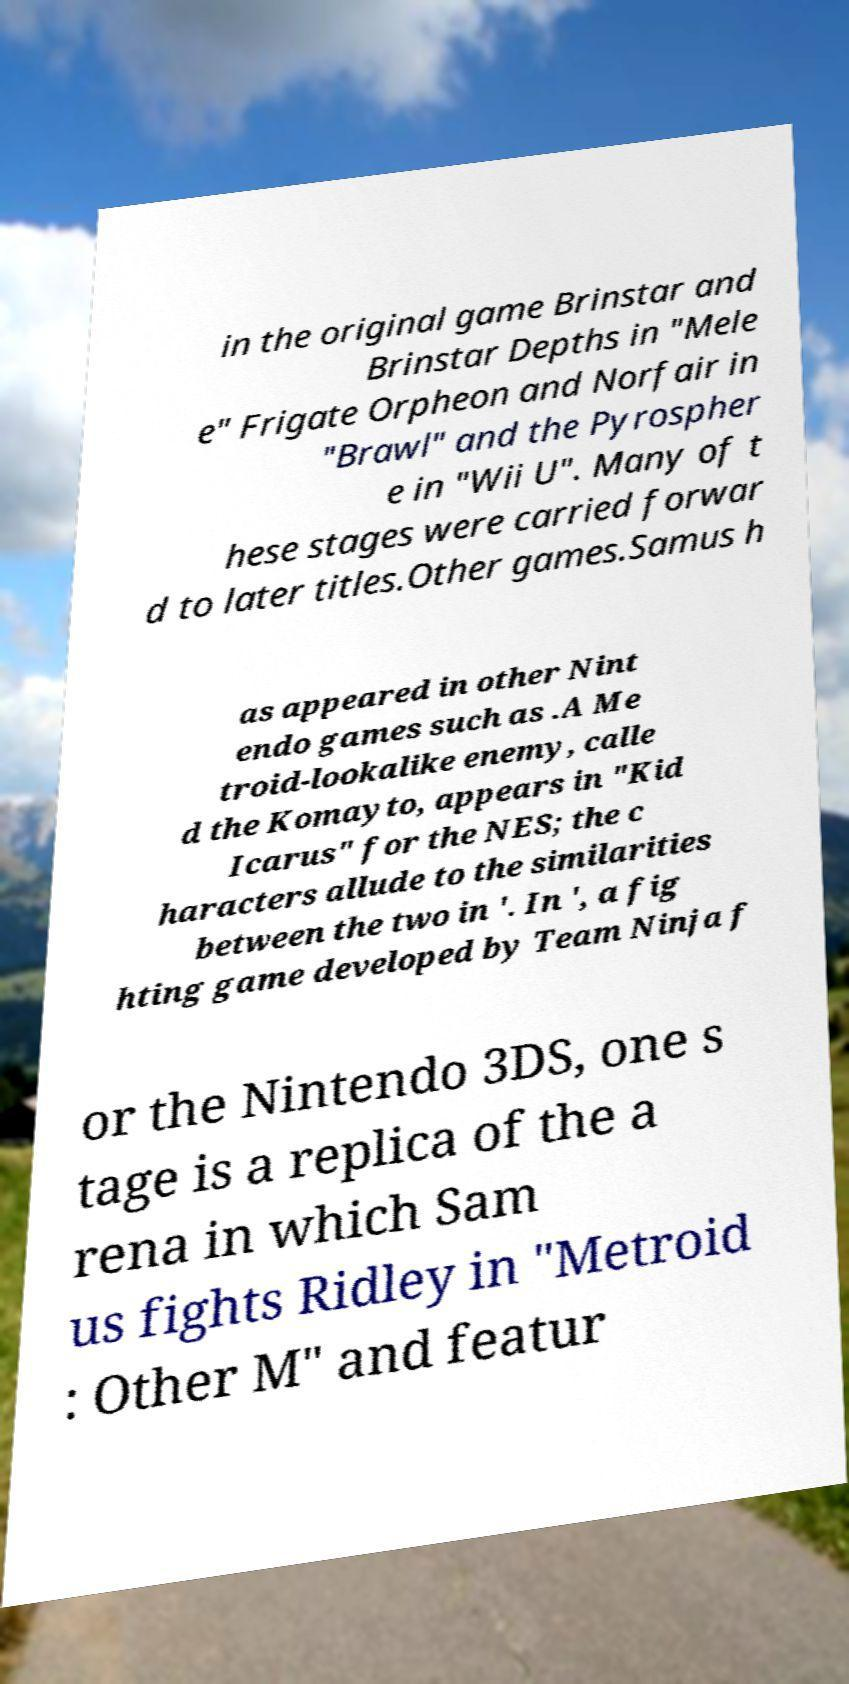There's text embedded in this image that I need extracted. Can you transcribe it verbatim? in the original game Brinstar and Brinstar Depths in "Mele e" Frigate Orpheon and Norfair in "Brawl" and the Pyrospher e in "Wii U". Many of t hese stages were carried forwar d to later titles.Other games.Samus h as appeared in other Nint endo games such as .A Me troid-lookalike enemy, calle d the Komayto, appears in "Kid Icarus" for the NES; the c haracters allude to the similarities between the two in '. In ', a fig hting game developed by Team Ninja f or the Nintendo 3DS, one s tage is a replica of the a rena in which Sam us fights Ridley in "Metroid : Other M" and featur 